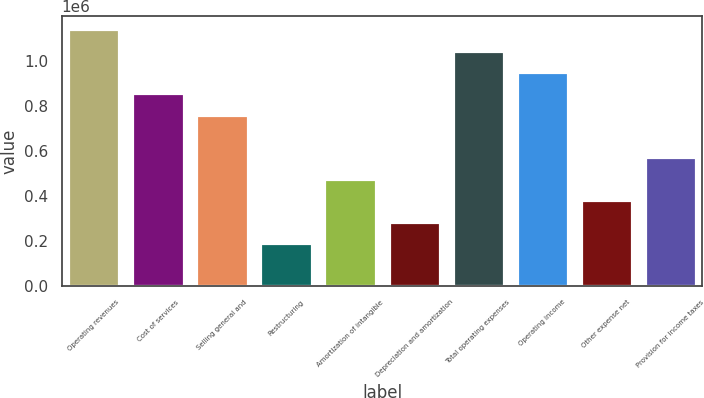Convert chart to OTSL. <chart><loc_0><loc_0><loc_500><loc_500><bar_chart><fcel>Operating revenues<fcel>Cost of services<fcel>Selling general and<fcel>Restructuring<fcel>Amortization of intangible<fcel>Depreciation and amortization<fcel>Total operating expenses<fcel>Operating income<fcel>Other expense net<fcel>Provision for income taxes<nl><fcel>1.14017e+06<fcel>855127<fcel>760113<fcel>190029<fcel>475071<fcel>285043<fcel>1.04515e+06<fcel>950141<fcel>380057<fcel>570085<nl></chart> 